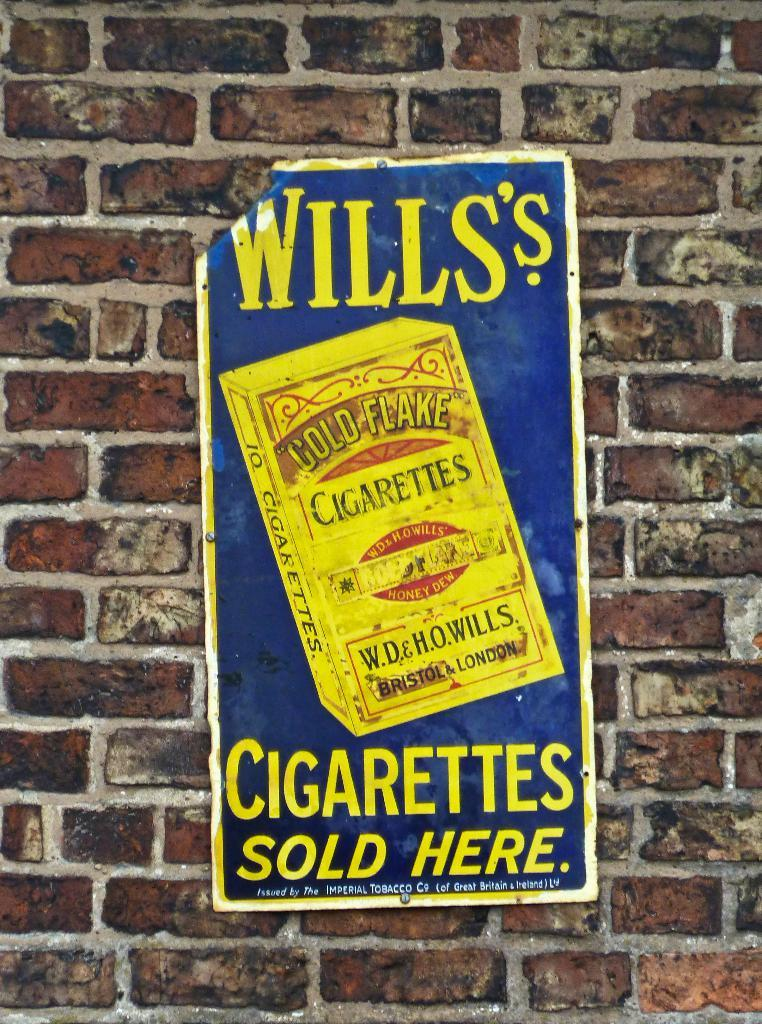Provide a one-sentence caption for the provided image. A vintage sign advertising Wills's Cigarettes sold here. 